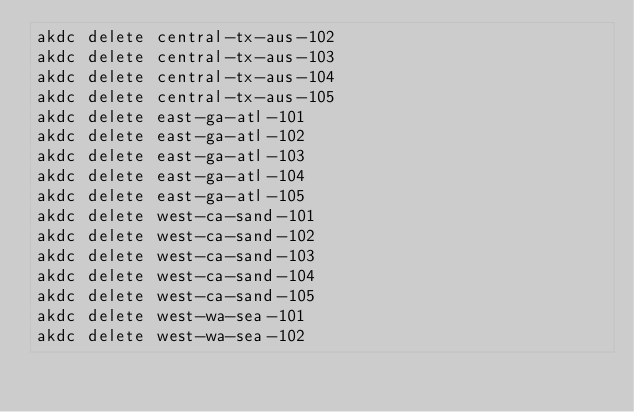<code> <loc_0><loc_0><loc_500><loc_500><_Bash_>akdc delete central-tx-aus-102
akdc delete central-tx-aus-103
akdc delete central-tx-aus-104
akdc delete central-tx-aus-105
akdc delete east-ga-atl-101
akdc delete east-ga-atl-102
akdc delete east-ga-atl-103
akdc delete east-ga-atl-104
akdc delete east-ga-atl-105
akdc delete west-ca-sand-101
akdc delete west-ca-sand-102
akdc delete west-ca-sand-103
akdc delete west-ca-sand-104
akdc delete west-ca-sand-105
akdc delete west-wa-sea-101
akdc delete west-wa-sea-102</code> 